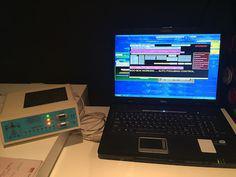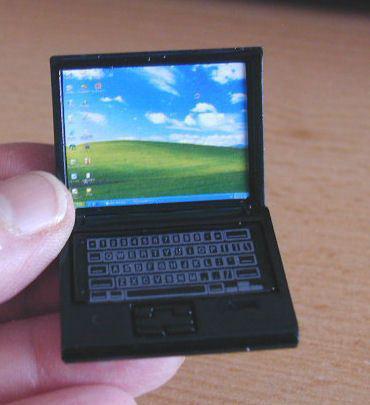The first image is the image on the left, the second image is the image on the right. Examine the images to the left and right. Is the description "Both images contain no more than one laptop." accurate? Answer yes or no. Yes. The first image is the image on the left, the second image is the image on the right. Given the left and right images, does the statement "Multiple laptops have the same blue screen showing." hold true? Answer yes or no. No. 